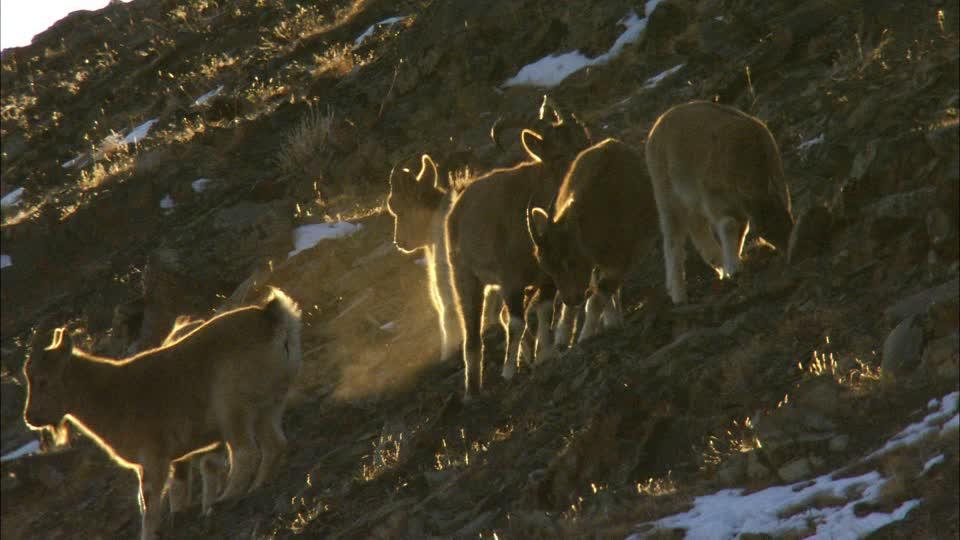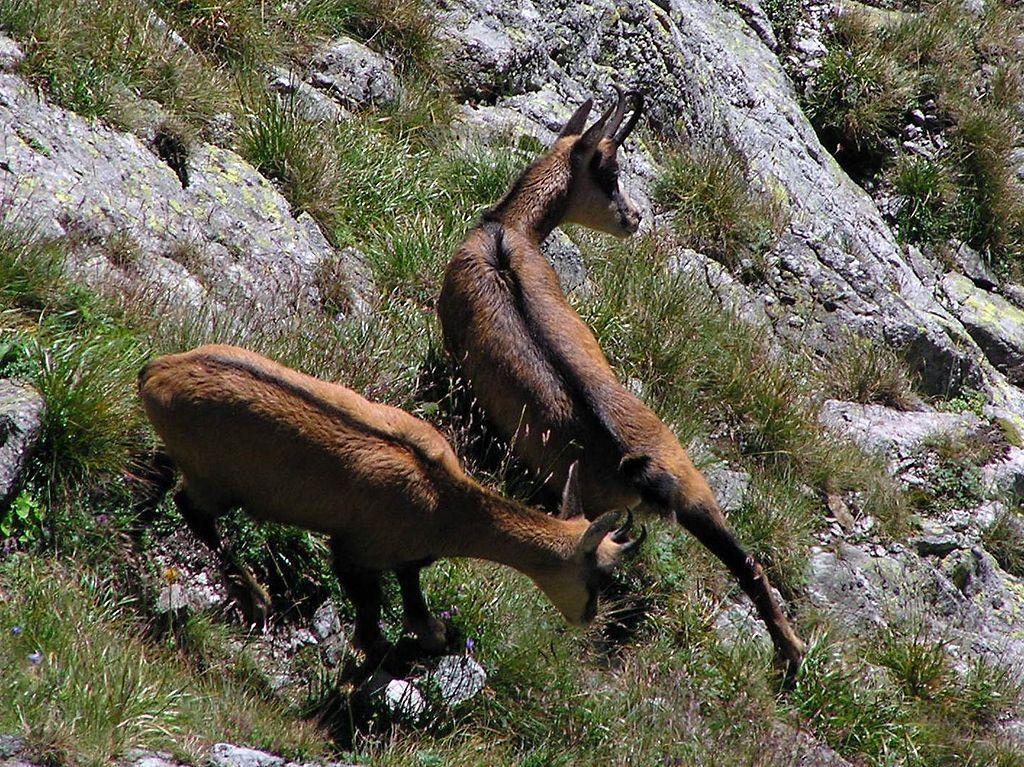The first image is the image on the left, the second image is the image on the right. Analyze the images presented: Is the assertion "Four or fewer goats are visible." valid? Answer yes or no. No. The first image is the image on the left, the second image is the image on the right. Assess this claim about the two images: "The left image shows at least one goat with very long horns on its head.". Correct or not? Answer yes or no. No. 